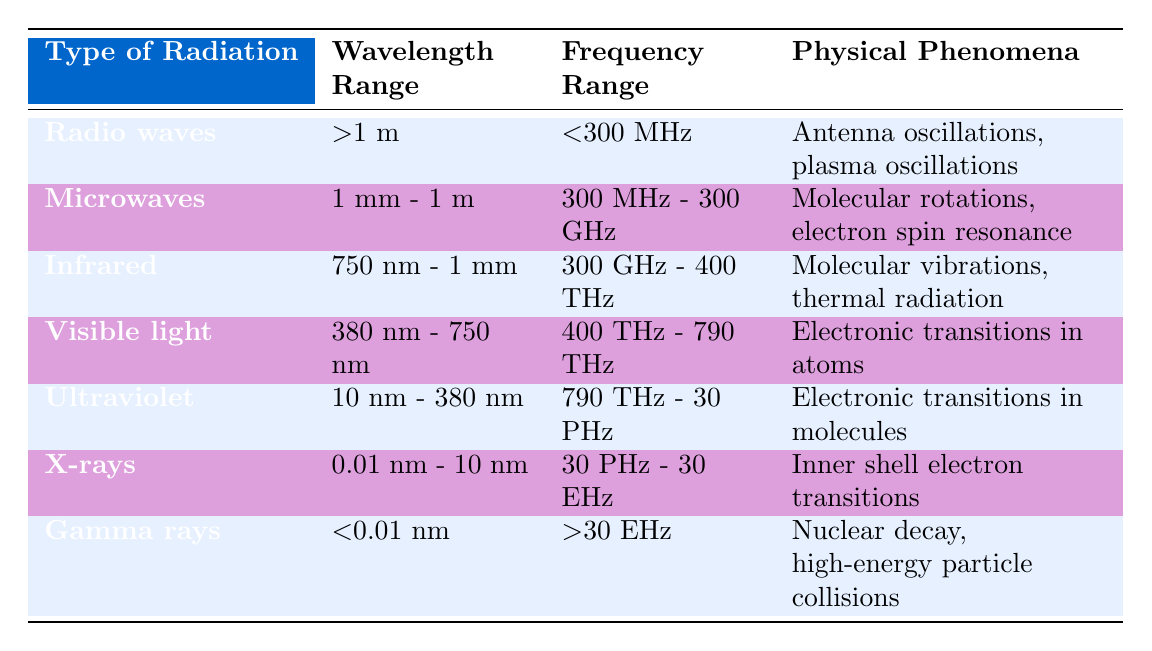What is the wavelength range of visible light? The table specifies that the wavelength range for visible light is between 380 nm and 750 nm. It directly identifies this data from the corresponding row.
Answer: 380 nm - 750 nm Which type of radiation has a frequency range greater than 30 EHz? By examining the table, I can see that the gamma rays have a frequency range of greater than 30 EHz. This is found in the frequency range column for the gamma rays row.
Answer: Gamma rays What is the wavelength range of microwaves and how does it compare to infrared? The wavelength range of microwaves is 1 mm to 1 m while infrared has a wavelength range of 750 nm to 1 mm. Since both ranges overlap at 1 mm, microwaves have a wider range starting from 1 mm to 1 m compared to infrared that starts from 750 nm.
Answer: Microwaves: 1 mm - 1 m; Infrared: 750 nm - 1 mm Is the frequency range of ultraviolet radiation higher than that of infrared? Yes, by comparing the frequency ranges, ultraviolet radiation spans from 790 THz to 30 PHz, while infrared radiation ranges from 300 GHz to 400 THz. Since 790 THz is greater than 400 THz, ultraviolet has a higher frequency range.
Answer: Yes Which type of radiation is associated with nuclear decay? The table shows that gamma rays are associated with nuclear decay, as stated in the physical phenomena column for gamma rays. This is a clear identification from the corresponding row.
Answer: Gamma rays What is the average frequency range of infrared and visible light? Infrared has a frequency range of 300 GHz to 400 THz, while visible light ranges from 400 THz to 790 THz. To find an average, consider the middle value of each range. The midpoint of infrared is 350 THz and for visible light it is 595 THz. The average of these midpoints is (350 + 595) / 2 = 472.5 THz.
Answer: 472.5 THz Which types of radiation have similar physical phenomena regarding electronic transitions? The table indicates that both visible light and ultraviolet radiation involve electronic transitions, but in different contexts (atoms and molecules). This is evident when reviewing the physical phenomena listed for both types.
Answer: Visible light and Ultraviolet How does the frequency of gamma rays compare to that of X-rays? Gamma rays have a frequency range of greater than 30 EHz whereas X-rays range from 30 PHz to 30 EHz. Since 30 EHz is greater than the maximum of X-rays, gamma rays indeed have a higher frequency range than X-rays.
Answer: Gamma rays > X-rays What is the physical phenomenon associated with radio waves? According to the table, the physical phenomena linked to radio waves are antenna oscillations and plasma oscillations, as noted in the specific row for radio waves.
Answer: Antenna oscillations, plasma oscillations 